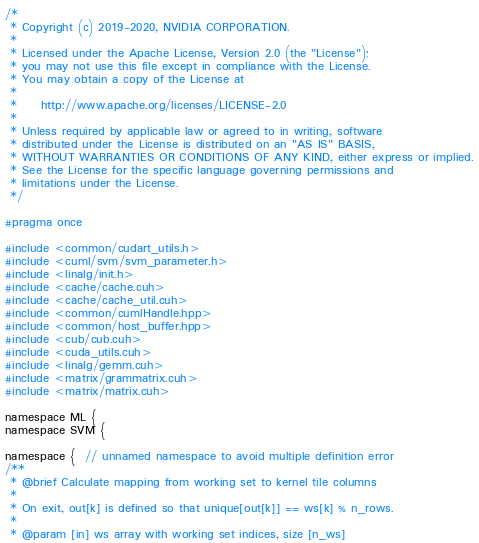<code> <loc_0><loc_0><loc_500><loc_500><_Cuda_>/*
 * Copyright (c) 2019-2020, NVIDIA CORPORATION.
 *
 * Licensed under the Apache License, Version 2.0 (the "License");
 * you may not use this file except in compliance with the License.
 * You may obtain a copy of the License at
 *
 *     http://www.apache.org/licenses/LICENSE-2.0
 *
 * Unless required by applicable law or agreed to in writing, software
 * distributed under the License is distributed on an "AS IS" BASIS,
 * WITHOUT WARRANTIES OR CONDITIONS OF ANY KIND, either express or implied.
 * See the License for the specific language governing permissions and
 * limitations under the License.
 */

#pragma once

#include <common/cudart_utils.h>
#include <cuml/svm/svm_parameter.h>
#include <linalg/init.h>
#include <cache/cache.cuh>
#include <cache/cache_util.cuh>
#include <common/cumlHandle.hpp>
#include <common/host_buffer.hpp>
#include <cub/cub.cuh>
#include <cuda_utils.cuh>
#include <linalg/gemm.cuh>
#include <matrix/grammatrix.cuh>
#include <matrix/matrix.cuh>

namespace ML {
namespace SVM {

namespace {  // unnamed namespace to avoid multiple definition error
/**
 * @brief Calculate mapping from working set to kernel tile columns
 *
 * On exit, out[k] is defined so that unique[out[k]] == ws[k] % n_rows.
 *
 * @param [in] ws array with working set indices, size [n_ws]</code> 